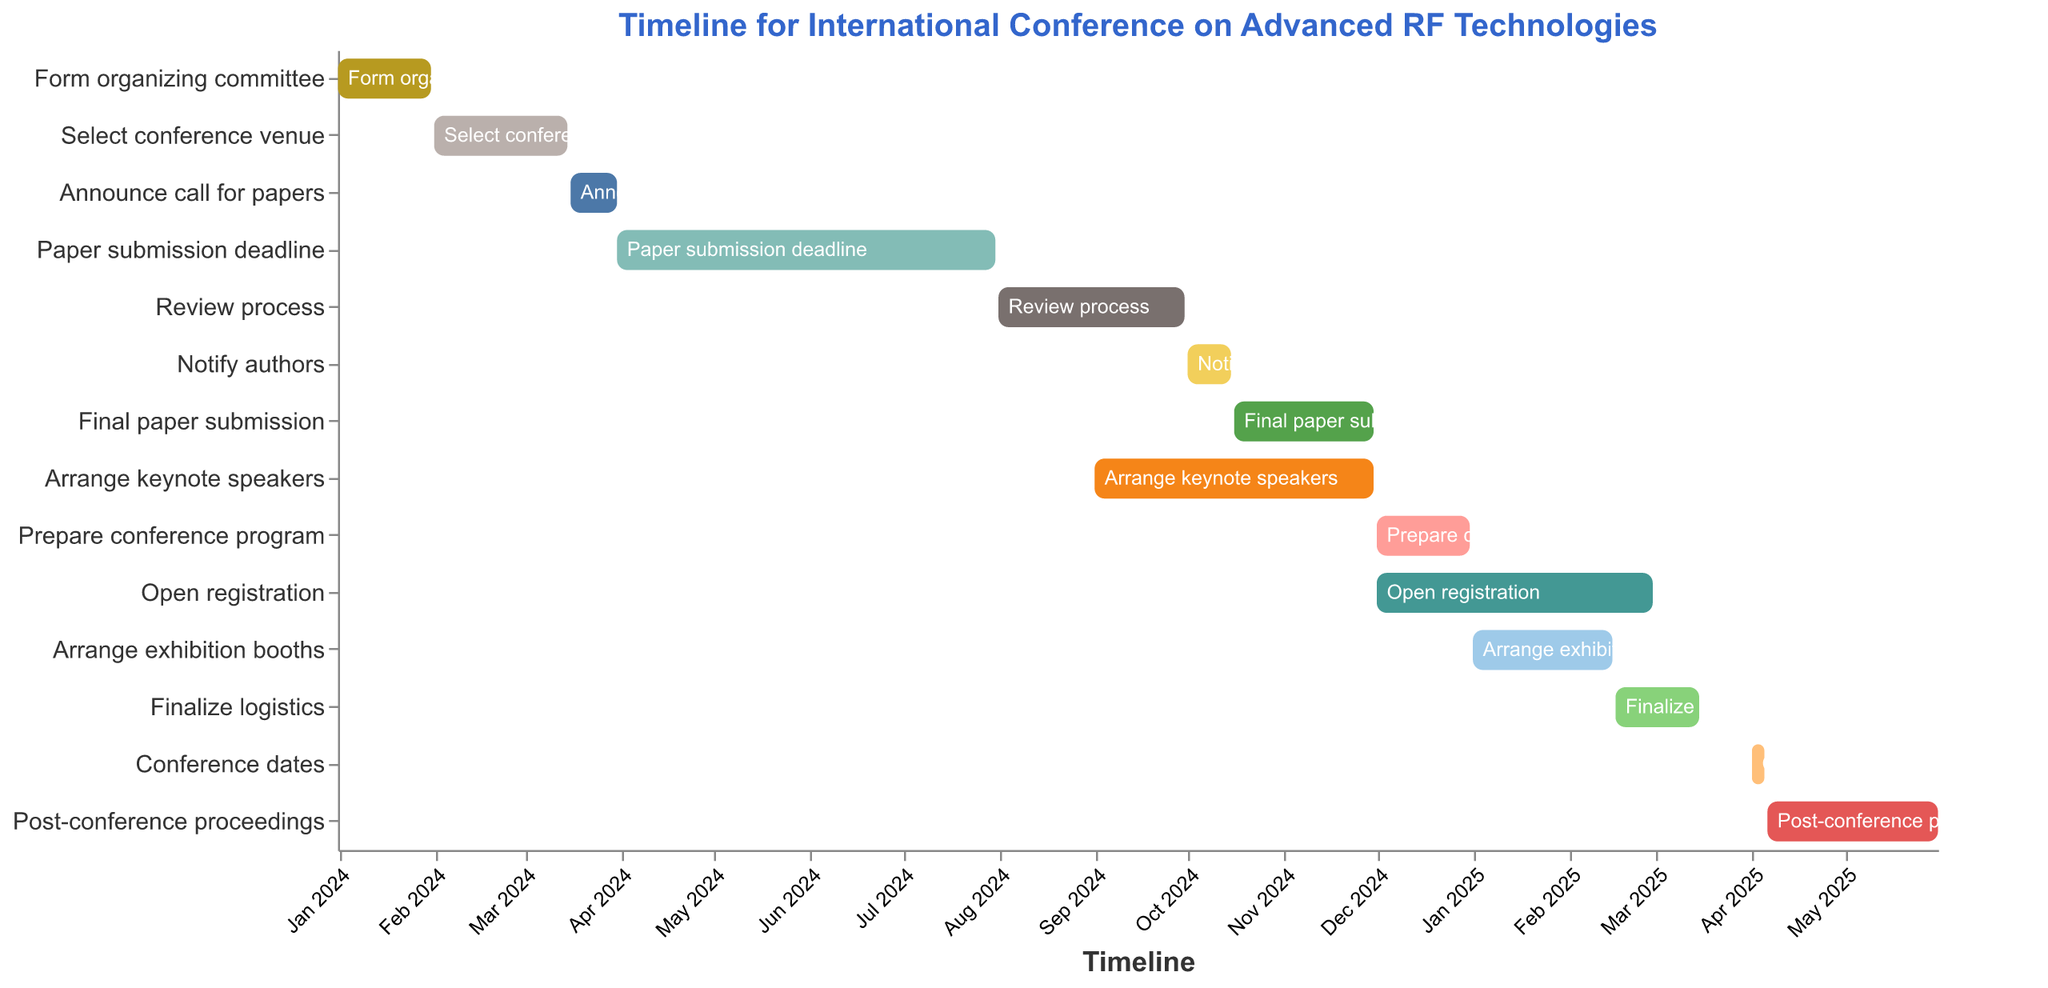What is the title of the chart? The title of the chart is typically displayed at the top of the figure in a larger font. For this chart, the title is specified to be "Timeline for International Conference on Advanced RF Technologies."
Answer: Timeline for International Conference on Advanced RF Technologies How long does the paper submission process last? To answer this, we look at the "Paper submission deadline" task's start and end dates. The start date is 2024-03-31 and the end date is 2024-07-31. The duration is the time span between these dates.
Answer: 4 months Which task ends first: "Form organizing committee" or "Select conference venue"? We examine the end dates of both tasks. "Form organizing committee" ends on 2024-01-31, and "Select conference venue" ends on 2024-03-15. Comparing these two dates, we see that the former ends first.
Answer: Form organizing committee When does the "Review process" start and end? The start and end dates for the "Review process" can be found directly in the data. According to the figure, it starts on 2024-08-01 and ends on 2024-09-30.
Answer: Starts on 2024-08-01 and ends on 2024-09-30 What task(s) overlap with the "Arrange keynote speakers” period? Look at the time range for "Arrange keynote speakers" (2024-09-01 to 2024-11-30). Any task whose duration overlaps with this range is considered. They are "Review process" (ends on 2024-09-30), "Notify authors," "Final paper submission," and "Arrange keynote speakers" itself.
Answer: Review process, Notify authors, Final paper submission How long is the "Finalize logistics" task? The task "Finalize logistics" starts on 2025-02-16 and ends on 2025-03-15. The duration is the number of days between these dates.
Answer: Approximately 4 weeks During which months is the "Open registration" task active? The "Open registration" task starts on 2024-12-01 and ends on 2025-02-28. This period spans parts of December, January, and February.
Answer: December, January, and February Which tasks are active in March 2024? Check each task to see if its duration includes any part of March 2024. "Select conference venue" and "Announce call for papers" are the tasks active during this period.
Answer: Select conference venue, Announce call for papers Does the "Post-conference proceedings" task extend beyond May 2025? Check the end date for "Post-conference proceedings" which is 2025-05-31. Since May 31 is within May, it does not extend beyond May 2025.
Answer: No 